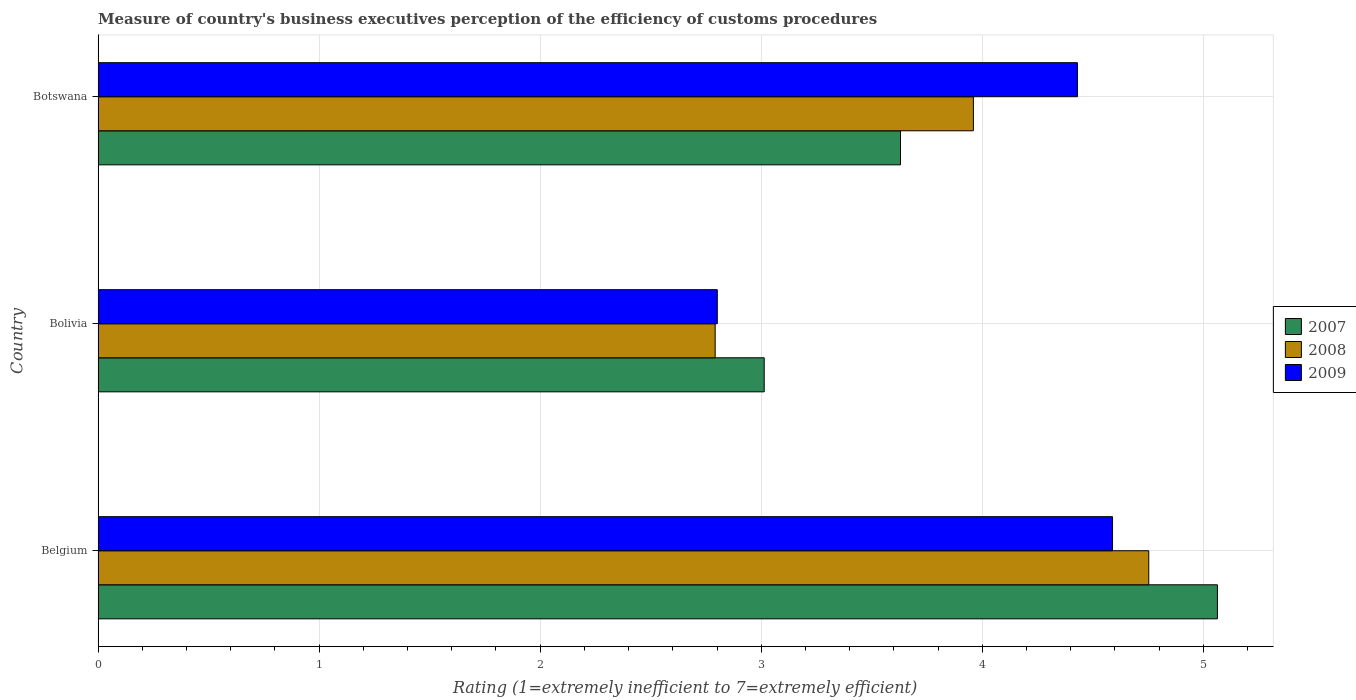How many different coloured bars are there?
Your answer should be compact. 3. How many bars are there on the 2nd tick from the bottom?
Your answer should be very brief. 3. What is the label of the 2nd group of bars from the top?
Your response must be concise. Bolivia. In how many cases, is the number of bars for a given country not equal to the number of legend labels?
Provide a succinct answer. 0. What is the rating of the efficiency of customs procedure in 2009 in Belgium?
Ensure brevity in your answer.  4.59. Across all countries, what is the maximum rating of the efficiency of customs procedure in 2008?
Provide a succinct answer. 4.75. Across all countries, what is the minimum rating of the efficiency of customs procedure in 2008?
Offer a very short reply. 2.79. What is the total rating of the efficiency of customs procedure in 2007 in the graph?
Ensure brevity in your answer.  11.71. What is the difference between the rating of the efficiency of customs procedure in 2007 in Belgium and that in Botswana?
Offer a very short reply. 1.43. What is the difference between the rating of the efficiency of customs procedure in 2009 in Bolivia and the rating of the efficiency of customs procedure in 2007 in Botswana?
Make the answer very short. -0.83. What is the average rating of the efficiency of customs procedure in 2009 per country?
Give a very brief answer. 3.94. What is the difference between the rating of the efficiency of customs procedure in 2008 and rating of the efficiency of customs procedure in 2009 in Botswana?
Your answer should be compact. -0.47. In how many countries, is the rating of the efficiency of customs procedure in 2009 greater than 2.8 ?
Offer a very short reply. 3. What is the ratio of the rating of the efficiency of customs procedure in 2008 in Belgium to that in Bolivia?
Provide a short and direct response. 1.7. Is the rating of the efficiency of customs procedure in 2009 in Belgium less than that in Botswana?
Give a very brief answer. No. What is the difference between the highest and the second highest rating of the efficiency of customs procedure in 2007?
Provide a succinct answer. 1.43. What is the difference between the highest and the lowest rating of the efficiency of customs procedure in 2008?
Your answer should be compact. 1.96. What does the 2nd bar from the top in Belgium represents?
Make the answer very short. 2008. What does the 2nd bar from the bottom in Belgium represents?
Keep it short and to the point. 2008. Is it the case that in every country, the sum of the rating of the efficiency of customs procedure in 2007 and rating of the efficiency of customs procedure in 2009 is greater than the rating of the efficiency of customs procedure in 2008?
Your response must be concise. Yes. Are all the bars in the graph horizontal?
Ensure brevity in your answer.  Yes. How many countries are there in the graph?
Offer a terse response. 3. What is the difference between two consecutive major ticks on the X-axis?
Ensure brevity in your answer.  1. Are the values on the major ticks of X-axis written in scientific E-notation?
Your response must be concise. No. Does the graph contain grids?
Make the answer very short. Yes. What is the title of the graph?
Your answer should be very brief. Measure of country's business executives perception of the efficiency of customs procedures. Does "1974" appear as one of the legend labels in the graph?
Provide a succinct answer. No. What is the label or title of the X-axis?
Provide a succinct answer. Rating (1=extremely inefficient to 7=extremely efficient). What is the label or title of the Y-axis?
Your answer should be very brief. Country. What is the Rating (1=extremely inefficient to 7=extremely efficient) in 2007 in Belgium?
Your response must be concise. 5.06. What is the Rating (1=extremely inefficient to 7=extremely efficient) of 2008 in Belgium?
Offer a very short reply. 4.75. What is the Rating (1=extremely inefficient to 7=extremely efficient) of 2009 in Belgium?
Provide a short and direct response. 4.59. What is the Rating (1=extremely inefficient to 7=extremely efficient) in 2007 in Bolivia?
Your response must be concise. 3.01. What is the Rating (1=extremely inefficient to 7=extremely efficient) of 2008 in Bolivia?
Provide a succinct answer. 2.79. What is the Rating (1=extremely inefficient to 7=extremely efficient) in 2009 in Bolivia?
Your answer should be very brief. 2.8. What is the Rating (1=extremely inefficient to 7=extremely efficient) in 2007 in Botswana?
Offer a terse response. 3.63. What is the Rating (1=extremely inefficient to 7=extremely efficient) of 2008 in Botswana?
Offer a terse response. 3.96. What is the Rating (1=extremely inefficient to 7=extremely efficient) of 2009 in Botswana?
Provide a succinct answer. 4.43. Across all countries, what is the maximum Rating (1=extremely inefficient to 7=extremely efficient) of 2007?
Give a very brief answer. 5.06. Across all countries, what is the maximum Rating (1=extremely inefficient to 7=extremely efficient) of 2008?
Offer a terse response. 4.75. Across all countries, what is the maximum Rating (1=extremely inefficient to 7=extremely efficient) of 2009?
Give a very brief answer. 4.59. Across all countries, what is the minimum Rating (1=extremely inefficient to 7=extremely efficient) in 2007?
Keep it short and to the point. 3.01. Across all countries, what is the minimum Rating (1=extremely inefficient to 7=extremely efficient) of 2008?
Keep it short and to the point. 2.79. Across all countries, what is the minimum Rating (1=extremely inefficient to 7=extremely efficient) in 2009?
Provide a succinct answer. 2.8. What is the total Rating (1=extremely inefficient to 7=extremely efficient) of 2007 in the graph?
Your response must be concise. 11.71. What is the total Rating (1=extremely inefficient to 7=extremely efficient) of 2008 in the graph?
Provide a succinct answer. 11.51. What is the total Rating (1=extremely inefficient to 7=extremely efficient) of 2009 in the graph?
Ensure brevity in your answer.  11.82. What is the difference between the Rating (1=extremely inefficient to 7=extremely efficient) in 2007 in Belgium and that in Bolivia?
Offer a very short reply. 2.05. What is the difference between the Rating (1=extremely inefficient to 7=extremely efficient) of 2008 in Belgium and that in Bolivia?
Give a very brief answer. 1.96. What is the difference between the Rating (1=extremely inefficient to 7=extremely efficient) of 2009 in Belgium and that in Bolivia?
Your response must be concise. 1.79. What is the difference between the Rating (1=extremely inefficient to 7=extremely efficient) of 2007 in Belgium and that in Botswana?
Your response must be concise. 1.43. What is the difference between the Rating (1=extremely inefficient to 7=extremely efficient) in 2008 in Belgium and that in Botswana?
Make the answer very short. 0.79. What is the difference between the Rating (1=extremely inefficient to 7=extremely efficient) in 2009 in Belgium and that in Botswana?
Provide a succinct answer. 0.16. What is the difference between the Rating (1=extremely inefficient to 7=extremely efficient) in 2007 in Bolivia and that in Botswana?
Make the answer very short. -0.62. What is the difference between the Rating (1=extremely inefficient to 7=extremely efficient) of 2008 in Bolivia and that in Botswana?
Offer a very short reply. -1.17. What is the difference between the Rating (1=extremely inefficient to 7=extremely efficient) in 2009 in Bolivia and that in Botswana?
Give a very brief answer. -1.63. What is the difference between the Rating (1=extremely inefficient to 7=extremely efficient) of 2007 in Belgium and the Rating (1=extremely inefficient to 7=extremely efficient) of 2008 in Bolivia?
Keep it short and to the point. 2.27. What is the difference between the Rating (1=extremely inefficient to 7=extremely efficient) of 2007 in Belgium and the Rating (1=extremely inefficient to 7=extremely efficient) of 2009 in Bolivia?
Offer a very short reply. 2.26. What is the difference between the Rating (1=extremely inefficient to 7=extremely efficient) of 2008 in Belgium and the Rating (1=extremely inefficient to 7=extremely efficient) of 2009 in Bolivia?
Ensure brevity in your answer.  1.95. What is the difference between the Rating (1=extremely inefficient to 7=extremely efficient) of 2007 in Belgium and the Rating (1=extremely inefficient to 7=extremely efficient) of 2008 in Botswana?
Offer a terse response. 1.1. What is the difference between the Rating (1=extremely inefficient to 7=extremely efficient) in 2007 in Belgium and the Rating (1=extremely inefficient to 7=extremely efficient) in 2009 in Botswana?
Your response must be concise. 0.63. What is the difference between the Rating (1=extremely inefficient to 7=extremely efficient) in 2008 in Belgium and the Rating (1=extremely inefficient to 7=extremely efficient) in 2009 in Botswana?
Keep it short and to the point. 0.32. What is the difference between the Rating (1=extremely inefficient to 7=extremely efficient) of 2007 in Bolivia and the Rating (1=extremely inefficient to 7=extremely efficient) of 2008 in Botswana?
Make the answer very short. -0.95. What is the difference between the Rating (1=extremely inefficient to 7=extremely efficient) of 2007 in Bolivia and the Rating (1=extremely inefficient to 7=extremely efficient) of 2009 in Botswana?
Provide a succinct answer. -1.42. What is the difference between the Rating (1=extremely inefficient to 7=extremely efficient) in 2008 in Bolivia and the Rating (1=extremely inefficient to 7=extremely efficient) in 2009 in Botswana?
Provide a short and direct response. -1.64. What is the average Rating (1=extremely inefficient to 7=extremely efficient) in 2007 per country?
Your response must be concise. 3.9. What is the average Rating (1=extremely inefficient to 7=extremely efficient) in 2008 per country?
Offer a very short reply. 3.83. What is the average Rating (1=extremely inefficient to 7=extremely efficient) of 2009 per country?
Ensure brevity in your answer.  3.94. What is the difference between the Rating (1=extremely inefficient to 7=extremely efficient) in 2007 and Rating (1=extremely inefficient to 7=extremely efficient) in 2008 in Belgium?
Provide a short and direct response. 0.31. What is the difference between the Rating (1=extremely inefficient to 7=extremely efficient) in 2007 and Rating (1=extremely inefficient to 7=extremely efficient) in 2009 in Belgium?
Offer a very short reply. 0.47. What is the difference between the Rating (1=extremely inefficient to 7=extremely efficient) of 2008 and Rating (1=extremely inefficient to 7=extremely efficient) of 2009 in Belgium?
Your answer should be compact. 0.16. What is the difference between the Rating (1=extremely inefficient to 7=extremely efficient) in 2007 and Rating (1=extremely inefficient to 7=extremely efficient) in 2008 in Bolivia?
Keep it short and to the point. 0.22. What is the difference between the Rating (1=extremely inefficient to 7=extremely efficient) of 2007 and Rating (1=extremely inefficient to 7=extremely efficient) of 2009 in Bolivia?
Provide a short and direct response. 0.21. What is the difference between the Rating (1=extremely inefficient to 7=extremely efficient) in 2008 and Rating (1=extremely inefficient to 7=extremely efficient) in 2009 in Bolivia?
Your answer should be compact. -0.01. What is the difference between the Rating (1=extremely inefficient to 7=extremely efficient) in 2007 and Rating (1=extremely inefficient to 7=extremely efficient) in 2008 in Botswana?
Provide a succinct answer. -0.33. What is the difference between the Rating (1=extremely inefficient to 7=extremely efficient) of 2007 and Rating (1=extremely inefficient to 7=extremely efficient) of 2009 in Botswana?
Provide a succinct answer. -0.8. What is the difference between the Rating (1=extremely inefficient to 7=extremely efficient) of 2008 and Rating (1=extremely inefficient to 7=extremely efficient) of 2009 in Botswana?
Your answer should be compact. -0.47. What is the ratio of the Rating (1=extremely inefficient to 7=extremely efficient) of 2007 in Belgium to that in Bolivia?
Your answer should be compact. 1.68. What is the ratio of the Rating (1=extremely inefficient to 7=extremely efficient) of 2008 in Belgium to that in Bolivia?
Offer a very short reply. 1.7. What is the ratio of the Rating (1=extremely inefficient to 7=extremely efficient) in 2009 in Belgium to that in Bolivia?
Ensure brevity in your answer.  1.64. What is the ratio of the Rating (1=extremely inefficient to 7=extremely efficient) of 2007 in Belgium to that in Botswana?
Provide a succinct answer. 1.39. What is the ratio of the Rating (1=extremely inefficient to 7=extremely efficient) in 2008 in Belgium to that in Botswana?
Your answer should be very brief. 1.2. What is the ratio of the Rating (1=extremely inefficient to 7=extremely efficient) in 2009 in Belgium to that in Botswana?
Your answer should be compact. 1.04. What is the ratio of the Rating (1=extremely inefficient to 7=extremely efficient) in 2007 in Bolivia to that in Botswana?
Provide a succinct answer. 0.83. What is the ratio of the Rating (1=extremely inefficient to 7=extremely efficient) of 2008 in Bolivia to that in Botswana?
Your answer should be very brief. 0.7. What is the ratio of the Rating (1=extremely inefficient to 7=extremely efficient) in 2009 in Bolivia to that in Botswana?
Provide a succinct answer. 0.63. What is the difference between the highest and the second highest Rating (1=extremely inefficient to 7=extremely efficient) in 2007?
Provide a succinct answer. 1.43. What is the difference between the highest and the second highest Rating (1=extremely inefficient to 7=extremely efficient) in 2008?
Provide a succinct answer. 0.79. What is the difference between the highest and the second highest Rating (1=extremely inefficient to 7=extremely efficient) of 2009?
Your answer should be compact. 0.16. What is the difference between the highest and the lowest Rating (1=extremely inefficient to 7=extremely efficient) of 2007?
Ensure brevity in your answer.  2.05. What is the difference between the highest and the lowest Rating (1=extremely inefficient to 7=extremely efficient) in 2008?
Make the answer very short. 1.96. What is the difference between the highest and the lowest Rating (1=extremely inefficient to 7=extremely efficient) of 2009?
Ensure brevity in your answer.  1.79. 